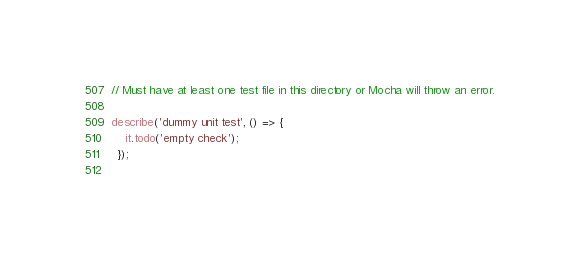<code> <loc_0><loc_0><loc_500><loc_500><_JavaScript_>// Must have at least one test file in this directory or Mocha will throw an error.

describe('dummy unit test', () => {
    it.todo('empty check');
  });
  </code> 